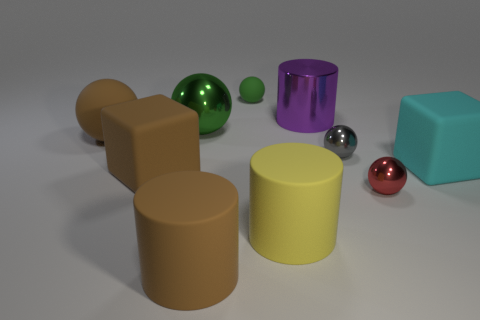There is a brown rubber object that is behind the cyan block; is it the same size as the tiny matte sphere?
Provide a short and direct response. No. How many things are large things or cyan objects?
Your answer should be very brief. 7. What material is the large sphere that is on the left side of the big block in front of the large block on the right side of the tiny rubber ball?
Your response must be concise. Rubber. What material is the red thing in front of the large brown sphere?
Offer a very short reply. Metal. Are there any other brown metallic spheres that have the same size as the brown ball?
Your answer should be compact. No. There is a ball that is behind the large purple metallic cylinder; is its color the same as the big metal cylinder?
Offer a terse response. No. How many gray things are either tiny rubber cylinders or cubes?
Your response must be concise. 0. What number of cubes have the same color as the tiny rubber sphere?
Offer a very short reply. 0. Are the brown block and the gray ball made of the same material?
Keep it short and to the point. No. What number of tiny red objects are to the left of the large cylinder that is in front of the large yellow object?
Give a very brief answer. 0. 